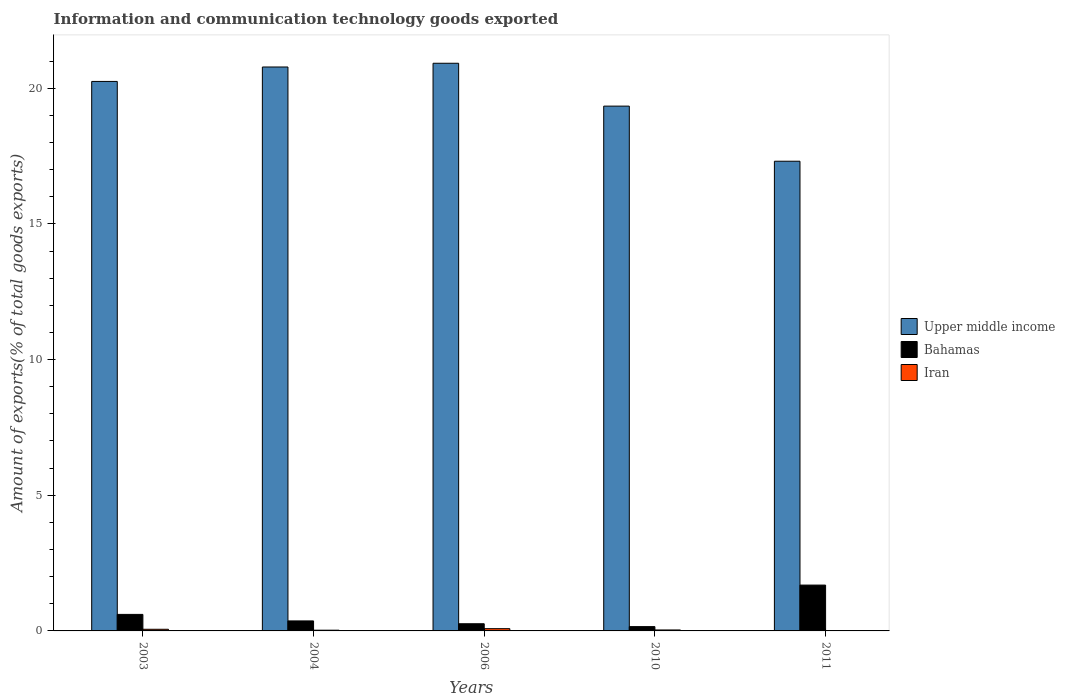How many groups of bars are there?
Give a very brief answer. 5. How many bars are there on the 2nd tick from the right?
Keep it short and to the point. 3. What is the label of the 4th group of bars from the left?
Keep it short and to the point. 2010. What is the amount of goods exported in Bahamas in 2003?
Provide a short and direct response. 0.61. Across all years, what is the maximum amount of goods exported in Iran?
Ensure brevity in your answer.  0.08. Across all years, what is the minimum amount of goods exported in Bahamas?
Ensure brevity in your answer.  0.16. In which year was the amount of goods exported in Iran minimum?
Give a very brief answer. 2011. What is the total amount of goods exported in Upper middle income in the graph?
Give a very brief answer. 98.61. What is the difference between the amount of goods exported in Bahamas in 2006 and that in 2010?
Offer a very short reply. 0.11. What is the difference between the amount of goods exported in Bahamas in 2003 and the amount of goods exported in Iran in 2004?
Provide a succinct answer. 0.58. What is the average amount of goods exported in Iran per year?
Your answer should be compact. 0.04. In the year 2011, what is the difference between the amount of goods exported in Upper middle income and amount of goods exported in Iran?
Give a very brief answer. 17.3. What is the ratio of the amount of goods exported in Bahamas in 2004 to that in 2006?
Keep it short and to the point. 1.39. Is the amount of goods exported in Iran in 2006 less than that in 2011?
Offer a terse response. No. Is the difference between the amount of goods exported in Upper middle income in 2003 and 2006 greater than the difference between the amount of goods exported in Iran in 2003 and 2006?
Offer a terse response. No. What is the difference between the highest and the second highest amount of goods exported in Upper middle income?
Provide a succinct answer. 0.14. What is the difference between the highest and the lowest amount of goods exported in Upper middle income?
Your answer should be very brief. 3.61. What does the 1st bar from the left in 2003 represents?
Make the answer very short. Upper middle income. What does the 1st bar from the right in 2011 represents?
Your answer should be very brief. Iran. Is it the case that in every year, the sum of the amount of goods exported in Upper middle income and amount of goods exported in Iran is greater than the amount of goods exported in Bahamas?
Offer a terse response. Yes. Are all the bars in the graph horizontal?
Provide a succinct answer. No. How many years are there in the graph?
Your answer should be very brief. 5. What is the difference between two consecutive major ticks on the Y-axis?
Keep it short and to the point. 5. Are the values on the major ticks of Y-axis written in scientific E-notation?
Ensure brevity in your answer.  No. Does the graph contain any zero values?
Keep it short and to the point. No. Does the graph contain grids?
Ensure brevity in your answer.  No. Where does the legend appear in the graph?
Your response must be concise. Center right. How many legend labels are there?
Keep it short and to the point. 3. What is the title of the graph?
Your response must be concise. Information and communication technology goods exported. Does "Middle East & North Africa (all income levels)" appear as one of the legend labels in the graph?
Offer a terse response. No. What is the label or title of the Y-axis?
Give a very brief answer. Amount of exports(% of total goods exports). What is the Amount of exports(% of total goods exports) in Upper middle income in 2003?
Provide a short and direct response. 20.25. What is the Amount of exports(% of total goods exports) of Bahamas in 2003?
Your answer should be very brief. 0.61. What is the Amount of exports(% of total goods exports) of Iran in 2003?
Offer a terse response. 0.06. What is the Amount of exports(% of total goods exports) in Upper middle income in 2004?
Offer a terse response. 20.78. What is the Amount of exports(% of total goods exports) in Bahamas in 2004?
Offer a very short reply. 0.37. What is the Amount of exports(% of total goods exports) of Iran in 2004?
Ensure brevity in your answer.  0.03. What is the Amount of exports(% of total goods exports) of Upper middle income in 2006?
Give a very brief answer. 20.92. What is the Amount of exports(% of total goods exports) in Bahamas in 2006?
Provide a succinct answer. 0.26. What is the Amount of exports(% of total goods exports) of Iran in 2006?
Your answer should be compact. 0.08. What is the Amount of exports(% of total goods exports) of Upper middle income in 2010?
Keep it short and to the point. 19.34. What is the Amount of exports(% of total goods exports) in Bahamas in 2010?
Ensure brevity in your answer.  0.16. What is the Amount of exports(% of total goods exports) of Iran in 2010?
Make the answer very short. 0.04. What is the Amount of exports(% of total goods exports) in Upper middle income in 2011?
Ensure brevity in your answer.  17.31. What is the Amount of exports(% of total goods exports) in Bahamas in 2011?
Keep it short and to the point. 1.69. What is the Amount of exports(% of total goods exports) of Iran in 2011?
Provide a short and direct response. 0.01. Across all years, what is the maximum Amount of exports(% of total goods exports) of Upper middle income?
Make the answer very short. 20.92. Across all years, what is the maximum Amount of exports(% of total goods exports) in Bahamas?
Keep it short and to the point. 1.69. Across all years, what is the maximum Amount of exports(% of total goods exports) of Iran?
Ensure brevity in your answer.  0.08. Across all years, what is the minimum Amount of exports(% of total goods exports) of Upper middle income?
Provide a short and direct response. 17.31. Across all years, what is the minimum Amount of exports(% of total goods exports) in Bahamas?
Offer a very short reply. 0.16. Across all years, what is the minimum Amount of exports(% of total goods exports) in Iran?
Keep it short and to the point. 0.01. What is the total Amount of exports(% of total goods exports) in Upper middle income in the graph?
Make the answer very short. 98.61. What is the total Amount of exports(% of total goods exports) of Bahamas in the graph?
Make the answer very short. 3.09. What is the total Amount of exports(% of total goods exports) in Iran in the graph?
Offer a very short reply. 0.22. What is the difference between the Amount of exports(% of total goods exports) of Upper middle income in 2003 and that in 2004?
Your answer should be very brief. -0.53. What is the difference between the Amount of exports(% of total goods exports) of Bahamas in 2003 and that in 2004?
Provide a succinct answer. 0.24. What is the difference between the Amount of exports(% of total goods exports) of Iran in 2003 and that in 2004?
Provide a succinct answer. 0.03. What is the difference between the Amount of exports(% of total goods exports) in Upper middle income in 2003 and that in 2006?
Make the answer very short. -0.67. What is the difference between the Amount of exports(% of total goods exports) of Bahamas in 2003 and that in 2006?
Your answer should be very brief. 0.34. What is the difference between the Amount of exports(% of total goods exports) in Iran in 2003 and that in 2006?
Your answer should be compact. -0.02. What is the difference between the Amount of exports(% of total goods exports) of Upper middle income in 2003 and that in 2010?
Make the answer very short. 0.91. What is the difference between the Amount of exports(% of total goods exports) of Bahamas in 2003 and that in 2010?
Provide a short and direct response. 0.45. What is the difference between the Amount of exports(% of total goods exports) of Iran in 2003 and that in 2010?
Your answer should be very brief. 0.03. What is the difference between the Amount of exports(% of total goods exports) in Upper middle income in 2003 and that in 2011?
Provide a short and direct response. 2.94. What is the difference between the Amount of exports(% of total goods exports) in Bahamas in 2003 and that in 2011?
Your answer should be very brief. -1.08. What is the difference between the Amount of exports(% of total goods exports) of Iran in 2003 and that in 2011?
Ensure brevity in your answer.  0.05. What is the difference between the Amount of exports(% of total goods exports) of Upper middle income in 2004 and that in 2006?
Provide a succinct answer. -0.14. What is the difference between the Amount of exports(% of total goods exports) in Bahamas in 2004 and that in 2006?
Give a very brief answer. 0.1. What is the difference between the Amount of exports(% of total goods exports) of Iran in 2004 and that in 2006?
Make the answer very short. -0.06. What is the difference between the Amount of exports(% of total goods exports) of Upper middle income in 2004 and that in 2010?
Give a very brief answer. 1.44. What is the difference between the Amount of exports(% of total goods exports) in Bahamas in 2004 and that in 2010?
Your response must be concise. 0.21. What is the difference between the Amount of exports(% of total goods exports) in Iran in 2004 and that in 2010?
Give a very brief answer. -0.01. What is the difference between the Amount of exports(% of total goods exports) in Upper middle income in 2004 and that in 2011?
Ensure brevity in your answer.  3.47. What is the difference between the Amount of exports(% of total goods exports) in Bahamas in 2004 and that in 2011?
Provide a succinct answer. -1.32. What is the difference between the Amount of exports(% of total goods exports) in Iran in 2004 and that in 2011?
Offer a very short reply. 0.02. What is the difference between the Amount of exports(% of total goods exports) of Upper middle income in 2006 and that in 2010?
Ensure brevity in your answer.  1.58. What is the difference between the Amount of exports(% of total goods exports) in Bahamas in 2006 and that in 2010?
Give a very brief answer. 0.11. What is the difference between the Amount of exports(% of total goods exports) in Iran in 2006 and that in 2010?
Your answer should be very brief. 0.05. What is the difference between the Amount of exports(% of total goods exports) in Upper middle income in 2006 and that in 2011?
Your answer should be compact. 3.61. What is the difference between the Amount of exports(% of total goods exports) of Bahamas in 2006 and that in 2011?
Offer a terse response. -1.42. What is the difference between the Amount of exports(% of total goods exports) in Iran in 2006 and that in 2011?
Give a very brief answer. 0.07. What is the difference between the Amount of exports(% of total goods exports) of Upper middle income in 2010 and that in 2011?
Offer a terse response. 2.03. What is the difference between the Amount of exports(% of total goods exports) of Bahamas in 2010 and that in 2011?
Your answer should be very brief. -1.53. What is the difference between the Amount of exports(% of total goods exports) in Iran in 2010 and that in 2011?
Ensure brevity in your answer.  0.02. What is the difference between the Amount of exports(% of total goods exports) in Upper middle income in 2003 and the Amount of exports(% of total goods exports) in Bahamas in 2004?
Give a very brief answer. 19.88. What is the difference between the Amount of exports(% of total goods exports) of Upper middle income in 2003 and the Amount of exports(% of total goods exports) of Iran in 2004?
Your answer should be compact. 20.23. What is the difference between the Amount of exports(% of total goods exports) in Bahamas in 2003 and the Amount of exports(% of total goods exports) in Iran in 2004?
Offer a terse response. 0.58. What is the difference between the Amount of exports(% of total goods exports) of Upper middle income in 2003 and the Amount of exports(% of total goods exports) of Bahamas in 2006?
Offer a very short reply. 19.99. What is the difference between the Amount of exports(% of total goods exports) in Upper middle income in 2003 and the Amount of exports(% of total goods exports) in Iran in 2006?
Provide a succinct answer. 20.17. What is the difference between the Amount of exports(% of total goods exports) of Bahamas in 2003 and the Amount of exports(% of total goods exports) of Iran in 2006?
Your answer should be compact. 0.53. What is the difference between the Amount of exports(% of total goods exports) of Upper middle income in 2003 and the Amount of exports(% of total goods exports) of Bahamas in 2010?
Keep it short and to the point. 20.09. What is the difference between the Amount of exports(% of total goods exports) in Upper middle income in 2003 and the Amount of exports(% of total goods exports) in Iran in 2010?
Give a very brief answer. 20.22. What is the difference between the Amount of exports(% of total goods exports) of Bahamas in 2003 and the Amount of exports(% of total goods exports) of Iran in 2010?
Your answer should be compact. 0.57. What is the difference between the Amount of exports(% of total goods exports) in Upper middle income in 2003 and the Amount of exports(% of total goods exports) in Bahamas in 2011?
Ensure brevity in your answer.  18.56. What is the difference between the Amount of exports(% of total goods exports) in Upper middle income in 2003 and the Amount of exports(% of total goods exports) in Iran in 2011?
Offer a terse response. 20.24. What is the difference between the Amount of exports(% of total goods exports) in Bahamas in 2003 and the Amount of exports(% of total goods exports) in Iran in 2011?
Offer a terse response. 0.6. What is the difference between the Amount of exports(% of total goods exports) in Upper middle income in 2004 and the Amount of exports(% of total goods exports) in Bahamas in 2006?
Offer a terse response. 20.52. What is the difference between the Amount of exports(% of total goods exports) in Upper middle income in 2004 and the Amount of exports(% of total goods exports) in Iran in 2006?
Offer a terse response. 20.7. What is the difference between the Amount of exports(% of total goods exports) in Bahamas in 2004 and the Amount of exports(% of total goods exports) in Iran in 2006?
Ensure brevity in your answer.  0.29. What is the difference between the Amount of exports(% of total goods exports) of Upper middle income in 2004 and the Amount of exports(% of total goods exports) of Bahamas in 2010?
Keep it short and to the point. 20.63. What is the difference between the Amount of exports(% of total goods exports) of Upper middle income in 2004 and the Amount of exports(% of total goods exports) of Iran in 2010?
Your answer should be compact. 20.75. What is the difference between the Amount of exports(% of total goods exports) of Bahamas in 2004 and the Amount of exports(% of total goods exports) of Iran in 2010?
Ensure brevity in your answer.  0.33. What is the difference between the Amount of exports(% of total goods exports) in Upper middle income in 2004 and the Amount of exports(% of total goods exports) in Bahamas in 2011?
Offer a terse response. 19.1. What is the difference between the Amount of exports(% of total goods exports) in Upper middle income in 2004 and the Amount of exports(% of total goods exports) in Iran in 2011?
Give a very brief answer. 20.77. What is the difference between the Amount of exports(% of total goods exports) of Bahamas in 2004 and the Amount of exports(% of total goods exports) of Iran in 2011?
Provide a short and direct response. 0.36. What is the difference between the Amount of exports(% of total goods exports) in Upper middle income in 2006 and the Amount of exports(% of total goods exports) in Bahamas in 2010?
Give a very brief answer. 20.76. What is the difference between the Amount of exports(% of total goods exports) of Upper middle income in 2006 and the Amount of exports(% of total goods exports) of Iran in 2010?
Offer a very short reply. 20.89. What is the difference between the Amount of exports(% of total goods exports) in Bahamas in 2006 and the Amount of exports(% of total goods exports) in Iran in 2010?
Your answer should be compact. 0.23. What is the difference between the Amount of exports(% of total goods exports) in Upper middle income in 2006 and the Amount of exports(% of total goods exports) in Bahamas in 2011?
Keep it short and to the point. 19.23. What is the difference between the Amount of exports(% of total goods exports) in Upper middle income in 2006 and the Amount of exports(% of total goods exports) in Iran in 2011?
Make the answer very short. 20.91. What is the difference between the Amount of exports(% of total goods exports) of Bahamas in 2006 and the Amount of exports(% of total goods exports) of Iran in 2011?
Give a very brief answer. 0.25. What is the difference between the Amount of exports(% of total goods exports) in Upper middle income in 2010 and the Amount of exports(% of total goods exports) in Bahamas in 2011?
Give a very brief answer. 17.65. What is the difference between the Amount of exports(% of total goods exports) of Upper middle income in 2010 and the Amount of exports(% of total goods exports) of Iran in 2011?
Provide a succinct answer. 19.33. What is the difference between the Amount of exports(% of total goods exports) of Bahamas in 2010 and the Amount of exports(% of total goods exports) of Iran in 2011?
Provide a succinct answer. 0.15. What is the average Amount of exports(% of total goods exports) in Upper middle income per year?
Provide a succinct answer. 19.72. What is the average Amount of exports(% of total goods exports) in Bahamas per year?
Offer a very short reply. 0.62. What is the average Amount of exports(% of total goods exports) in Iran per year?
Ensure brevity in your answer.  0.04. In the year 2003, what is the difference between the Amount of exports(% of total goods exports) of Upper middle income and Amount of exports(% of total goods exports) of Bahamas?
Offer a very short reply. 19.64. In the year 2003, what is the difference between the Amount of exports(% of total goods exports) of Upper middle income and Amount of exports(% of total goods exports) of Iran?
Offer a terse response. 20.19. In the year 2003, what is the difference between the Amount of exports(% of total goods exports) in Bahamas and Amount of exports(% of total goods exports) in Iran?
Your answer should be very brief. 0.55. In the year 2004, what is the difference between the Amount of exports(% of total goods exports) in Upper middle income and Amount of exports(% of total goods exports) in Bahamas?
Make the answer very short. 20.42. In the year 2004, what is the difference between the Amount of exports(% of total goods exports) in Upper middle income and Amount of exports(% of total goods exports) in Iran?
Give a very brief answer. 20.76. In the year 2004, what is the difference between the Amount of exports(% of total goods exports) of Bahamas and Amount of exports(% of total goods exports) of Iran?
Make the answer very short. 0.34. In the year 2006, what is the difference between the Amount of exports(% of total goods exports) in Upper middle income and Amount of exports(% of total goods exports) in Bahamas?
Ensure brevity in your answer.  20.66. In the year 2006, what is the difference between the Amount of exports(% of total goods exports) in Upper middle income and Amount of exports(% of total goods exports) in Iran?
Make the answer very short. 20.84. In the year 2006, what is the difference between the Amount of exports(% of total goods exports) in Bahamas and Amount of exports(% of total goods exports) in Iran?
Your answer should be very brief. 0.18. In the year 2010, what is the difference between the Amount of exports(% of total goods exports) of Upper middle income and Amount of exports(% of total goods exports) of Bahamas?
Ensure brevity in your answer.  19.18. In the year 2010, what is the difference between the Amount of exports(% of total goods exports) of Upper middle income and Amount of exports(% of total goods exports) of Iran?
Offer a terse response. 19.31. In the year 2010, what is the difference between the Amount of exports(% of total goods exports) in Bahamas and Amount of exports(% of total goods exports) in Iran?
Keep it short and to the point. 0.12. In the year 2011, what is the difference between the Amount of exports(% of total goods exports) in Upper middle income and Amount of exports(% of total goods exports) in Bahamas?
Your answer should be compact. 15.62. In the year 2011, what is the difference between the Amount of exports(% of total goods exports) of Upper middle income and Amount of exports(% of total goods exports) of Iran?
Offer a very short reply. 17.3. In the year 2011, what is the difference between the Amount of exports(% of total goods exports) in Bahamas and Amount of exports(% of total goods exports) in Iran?
Keep it short and to the point. 1.68. What is the ratio of the Amount of exports(% of total goods exports) of Upper middle income in 2003 to that in 2004?
Offer a terse response. 0.97. What is the ratio of the Amount of exports(% of total goods exports) of Bahamas in 2003 to that in 2004?
Give a very brief answer. 1.65. What is the ratio of the Amount of exports(% of total goods exports) of Iran in 2003 to that in 2004?
Provide a short and direct response. 2.28. What is the ratio of the Amount of exports(% of total goods exports) in Upper middle income in 2003 to that in 2006?
Ensure brevity in your answer.  0.97. What is the ratio of the Amount of exports(% of total goods exports) in Bahamas in 2003 to that in 2006?
Your answer should be compact. 2.3. What is the ratio of the Amount of exports(% of total goods exports) in Iran in 2003 to that in 2006?
Provide a short and direct response. 0.73. What is the ratio of the Amount of exports(% of total goods exports) in Upper middle income in 2003 to that in 2010?
Your answer should be compact. 1.05. What is the ratio of the Amount of exports(% of total goods exports) in Bahamas in 2003 to that in 2010?
Your response must be concise. 3.84. What is the ratio of the Amount of exports(% of total goods exports) in Iran in 2003 to that in 2010?
Your answer should be very brief. 1.71. What is the ratio of the Amount of exports(% of total goods exports) in Upper middle income in 2003 to that in 2011?
Your response must be concise. 1.17. What is the ratio of the Amount of exports(% of total goods exports) of Bahamas in 2003 to that in 2011?
Keep it short and to the point. 0.36. What is the ratio of the Amount of exports(% of total goods exports) of Iran in 2003 to that in 2011?
Your answer should be very brief. 5.32. What is the ratio of the Amount of exports(% of total goods exports) of Bahamas in 2004 to that in 2006?
Give a very brief answer. 1.39. What is the ratio of the Amount of exports(% of total goods exports) in Iran in 2004 to that in 2006?
Offer a very short reply. 0.32. What is the ratio of the Amount of exports(% of total goods exports) of Upper middle income in 2004 to that in 2010?
Your answer should be very brief. 1.07. What is the ratio of the Amount of exports(% of total goods exports) in Bahamas in 2004 to that in 2010?
Keep it short and to the point. 2.32. What is the ratio of the Amount of exports(% of total goods exports) in Iran in 2004 to that in 2010?
Offer a very short reply. 0.75. What is the ratio of the Amount of exports(% of total goods exports) in Upper middle income in 2004 to that in 2011?
Offer a very short reply. 1.2. What is the ratio of the Amount of exports(% of total goods exports) in Bahamas in 2004 to that in 2011?
Provide a succinct answer. 0.22. What is the ratio of the Amount of exports(% of total goods exports) of Iran in 2004 to that in 2011?
Provide a succinct answer. 2.33. What is the ratio of the Amount of exports(% of total goods exports) in Upper middle income in 2006 to that in 2010?
Your answer should be compact. 1.08. What is the ratio of the Amount of exports(% of total goods exports) of Iran in 2006 to that in 2010?
Provide a short and direct response. 2.35. What is the ratio of the Amount of exports(% of total goods exports) in Upper middle income in 2006 to that in 2011?
Offer a terse response. 1.21. What is the ratio of the Amount of exports(% of total goods exports) in Bahamas in 2006 to that in 2011?
Offer a very short reply. 0.16. What is the ratio of the Amount of exports(% of total goods exports) in Iran in 2006 to that in 2011?
Make the answer very short. 7.33. What is the ratio of the Amount of exports(% of total goods exports) in Upper middle income in 2010 to that in 2011?
Your answer should be very brief. 1.12. What is the ratio of the Amount of exports(% of total goods exports) in Bahamas in 2010 to that in 2011?
Your answer should be very brief. 0.09. What is the ratio of the Amount of exports(% of total goods exports) of Iran in 2010 to that in 2011?
Keep it short and to the point. 3.12. What is the difference between the highest and the second highest Amount of exports(% of total goods exports) in Upper middle income?
Ensure brevity in your answer.  0.14. What is the difference between the highest and the second highest Amount of exports(% of total goods exports) in Bahamas?
Give a very brief answer. 1.08. What is the difference between the highest and the second highest Amount of exports(% of total goods exports) of Iran?
Your answer should be very brief. 0.02. What is the difference between the highest and the lowest Amount of exports(% of total goods exports) of Upper middle income?
Provide a succinct answer. 3.61. What is the difference between the highest and the lowest Amount of exports(% of total goods exports) of Bahamas?
Offer a terse response. 1.53. What is the difference between the highest and the lowest Amount of exports(% of total goods exports) in Iran?
Offer a terse response. 0.07. 